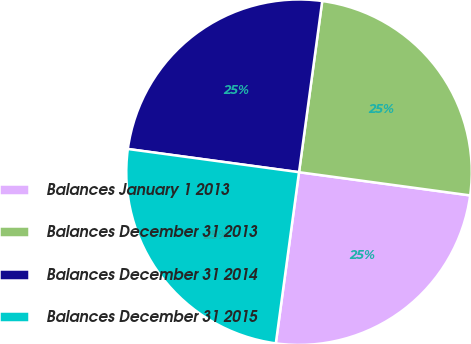Convert chart to OTSL. <chart><loc_0><loc_0><loc_500><loc_500><pie_chart><fcel>Balances January 1 2013<fcel>Balances December 31 2013<fcel>Balances December 31 2014<fcel>Balances December 31 2015<nl><fcel>25.0%<fcel>25.0%<fcel>25.0%<fcel>25.0%<nl></chart> 